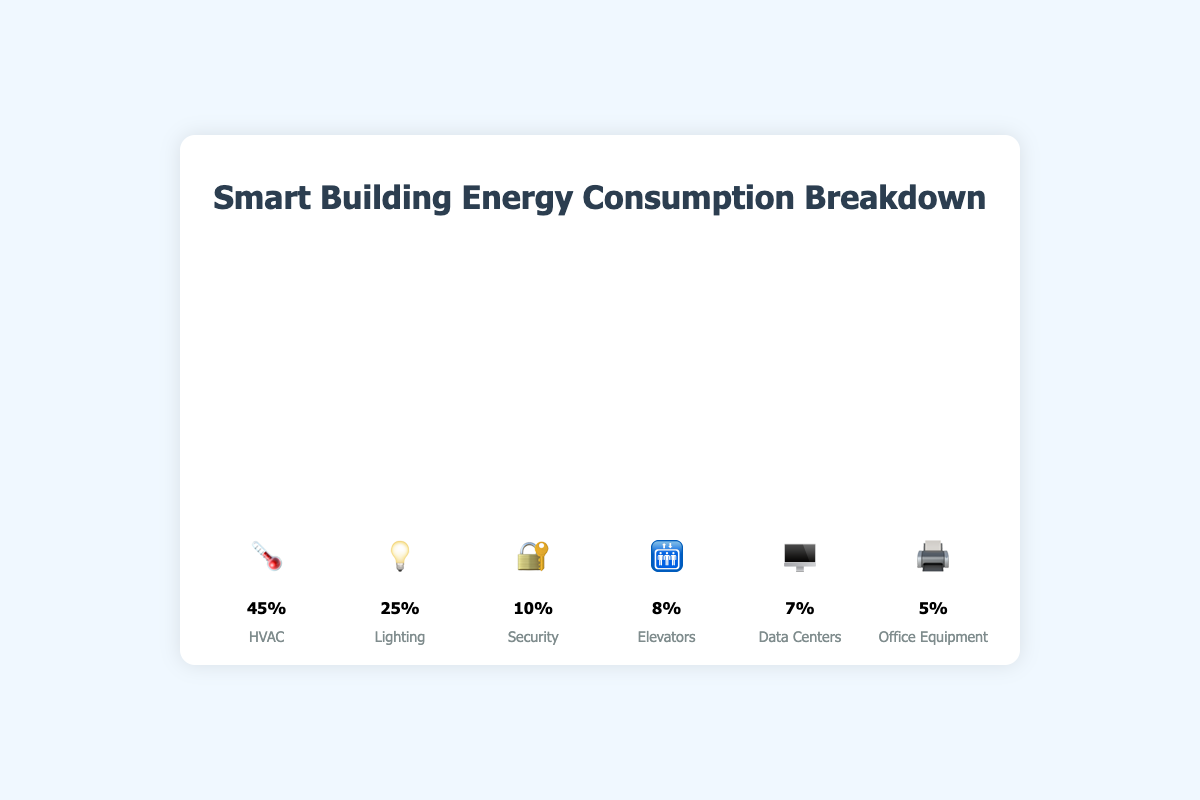What is the energy consumption percentage for HVAC? The figure shows a bar for HVAC indicated with the emoji 🌡️. The value next to the bar is 45%.
Answer: 45% Which system consumes the least energy? By comparing the percentages of all systems shown as bars with respective emojis, Office Equipment (🖨️) has the smallest bar with 5%.
Answer: Office Equipment How much more energy does HVAC consume compared to Lighting? The figure shows HVAC consumes 45% and Lighting consumes 25%. The difference is 45% - 25% = 20%.
Answer: 20% What is the combined energy consumption of Elevators and Data Centers? Elevators (🛗) consume 8%, and Data Centers (🖥️) consume 7%. Their combined consumption is 8% + 7% = 15%.
Answer: 15% Are there more systems consuming more than 10% or less than 10% of energy? The systems with more than 10% are HVAC (45%), Lighting (25%), and Security (10%). The systems with less than 10% are Elevators (8%), Data Centers (7%), and Office Equipment (5%). There are 3 systems in each category.
Answer: Equal Which system type has the second-highest energy consumption? Examining the bar heights, Lighting (💡) has 25%, making it the second highest after HVAC.
Answer: Lighting What is the total energy consumption percentage for Security, Elevators, and Office Equipment combined? Security (🔐) is 10%, Elevators (🛗) is 8%, and Office Equipment (🖨️) is 5%. The total is 10% + 8% + 5% = 23%.
Answer: 23% Which systems have energy consumption percentages more than double that of Data Centers? Data Centers (🖥️) consume 7%. Double of 7% is 14%. HVAC (45%) and Lighting (25%) both consume more than 14%.
Answer: HVAC and Lighting What is the difference between the highest and lowest energy-consuming systems? The highest is HVAC (45%) and the lowest is Office Equipment (5%). The difference is 45% - 5% = 40%.
Answer: 40% By how much does the energy consumption of Security exceed that of Office Equipment? Security (🔐) consumes 10% and Office Equipment (🖨️) consumes 5%. The difference is 10% - 5% = 5%.
Answer: 5% 